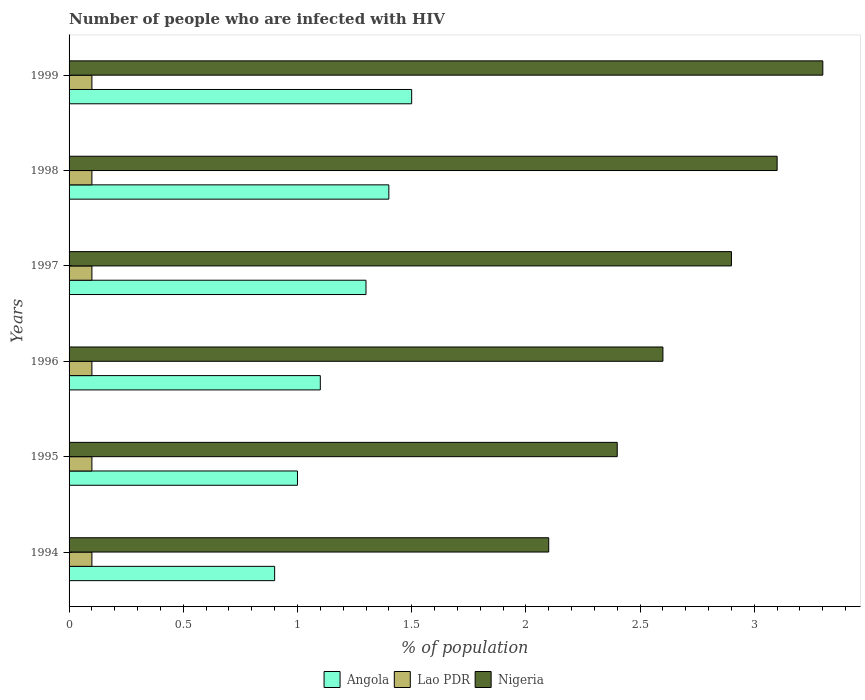How many different coloured bars are there?
Make the answer very short. 3. Are the number of bars per tick equal to the number of legend labels?
Keep it short and to the point. Yes. What is the label of the 4th group of bars from the top?
Your response must be concise. 1996. In how many cases, is the number of bars for a given year not equal to the number of legend labels?
Make the answer very short. 0. Across all years, what is the maximum percentage of HIV infected population in in Angola?
Your answer should be very brief. 1.5. Across all years, what is the minimum percentage of HIV infected population in in Nigeria?
Offer a very short reply. 2.1. In which year was the percentage of HIV infected population in in Angola minimum?
Ensure brevity in your answer.  1994. What is the total percentage of HIV infected population in in Nigeria in the graph?
Provide a short and direct response. 16.4. What is the difference between the percentage of HIV infected population in in Nigeria in 1997 and the percentage of HIV infected population in in Lao PDR in 1999?
Ensure brevity in your answer.  2.8. What is the average percentage of HIV infected population in in Angola per year?
Your answer should be very brief. 1.2. In the year 1995, what is the difference between the percentage of HIV infected population in in Nigeria and percentage of HIV infected population in in Angola?
Offer a very short reply. 1.4. In how many years, is the percentage of HIV infected population in in Lao PDR greater than 1.6 %?
Provide a succinct answer. 0. What is the ratio of the percentage of HIV infected population in in Lao PDR in 1995 to that in 1997?
Provide a succinct answer. 1. Is the percentage of HIV infected population in in Nigeria in 1994 less than that in 1995?
Keep it short and to the point. Yes. What is the difference between the highest and the second highest percentage of HIV infected population in in Angola?
Make the answer very short. 0.1. In how many years, is the percentage of HIV infected population in in Lao PDR greater than the average percentage of HIV infected population in in Lao PDR taken over all years?
Ensure brevity in your answer.  6. Is the sum of the percentage of HIV infected population in in Lao PDR in 1996 and 1997 greater than the maximum percentage of HIV infected population in in Nigeria across all years?
Provide a short and direct response. No. What does the 2nd bar from the top in 1995 represents?
Your response must be concise. Lao PDR. What does the 1st bar from the bottom in 1995 represents?
Give a very brief answer. Angola. Is it the case that in every year, the sum of the percentage of HIV infected population in in Angola and percentage of HIV infected population in in Lao PDR is greater than the percentage of HIV infected population in in Nigeria?
Provide a succinct answer. No. Are the values on the major ticks of X-axis written in scientific E-notation?
Keep it short and to the point. No. Does the graph contain any zero values?
Your answer should be very brief. No. Does the graph contain grids?
Give a very brief answer. No. How many legend labels are there?
Provide a succinct answer. 3. How are the legend labels stacked?
Your response must be concise. Horizontal. What is the title of the graph?
Keep it short and to the point. Number of people who are infected with HIV. Does "Italy" appear as one of the legend labels in the graph?
Provide a succinct answer. No. What is the label or title of the X-axis?
Give a very brief answer. % of population. What is the label or title of the Y-axis?
Your response must be concise. Years. What is the % of population in Angola in 1994?
Make the answer very short. 0.9. What is the % of population of Lao PDR in 1994?
Keep it short and to the point. 0.1. What is the % of population in Nigeria in 1994?
Your response must be concise. 2.1. What is the % of population in Angola in 1995?
Your response must be concise. 1. What is the % of population of Nigeria in 1995?
Your answer should be compact. 2.4. What is the % of population in Angola in 1996?
Make the answer very short. 1.1. What is the % of population of Lao PDR in 1996?
Give a very brief answer. 0.1. What is the % of population in Angola in 1998?
Keep it short and to the point. 1.4. What is the % of population of Nigeria in 1998?
Provide a short and direct response. 3.1. What is the % of population in Lao PDR in 1999?
Your answer should be very brief. 0.1. Across all years, what is the maximum % of population in Lao PDR?
Give a very brief answer. 0.1. Across all years, what is the minimum % of population of Angola?
Make the answer very short. 0.9. What is the total % of population of Angola in the graph?
Provide a short and direct response. 7.2. What is the difference between the % of population in Lao PDR in 1994 and that in 1995?
Your answer should be compact. 0. What is the difference between the % of population of Nigeria in 1994 and that in 1995?
Keep it short and to the point. -0.3. What is the difference between the % of population in Lao PDR in 1994 and that in 1996?
Your response must be concise. 0. What is the difference between the % of population of Nigeria in 1994 and that in 1996?
Provide a succinct answer. -0.5. What is the difference between the % of population of Lao PDR in 1994 and that in 1997?
Ensure brevity in your answer.  0. What is the difference between the % of population of Angola in 1994 and that in 1998?
Offer a terse response. -0.5. What is the difference between the % of population in Nigeria in 1994 and that in 1998?
Give a very brief answer. -1. What is the difference between the % of population in Nigeria in 1994 and that in 1999?
Your response must be concise. -1.2. What is the difference between the % of population of Angola in 1995 and that in 1998?
Keep it short and to the point. -0.4. What is the difference between the % of population of Nigeria in 1995 and that in 1998?
Give a very brief answer. -0.7. What is the difference between the % of population of Angola in 1995 and that in 1999?
Your response must be concise. -0.5. What is the difference between the % of population in Angola in 1996 and that in 1997?
Provide a short and direct response. -0.2. What is the difference between the % of population of Nigeria in 1996 and that in 1997?
Offer a terse response. -0.3. What is the difference between the % of population in Lao PDR in 1996 and that in 1999?
Offer a very short reply. 0. What is the difference between the % of population of Nigeria in 1996 and that in 1999?
Your response must be concise. -0.7. What is the difference between the % of population of Lao PDR in 1997 and that in 1998?
Make the answer very short. 0. What is the difference between the % of population of Angola in 1997 and that in 1999?
Give a very brief answer. -0.2. What is the difference between the % of population of Lao PDR in 1997 and that in 1999?
Offer a terse response. 0. What is the difference between the % of population in Nigeria in 1998 and that in 1999?
Make the answer very short. -0.2. What is the difference between the % of population of Angola in 1994 and the % of population of Lao PDR in 1995?
Make the answer very short. 0.8. What is the difference between the % of population of Lao PDR in 1994 and the % of population of Nigeria in 1995?
Your answer should be compact. -2.3. What is the difference between the % of population of Angola in 1994 and the % of population of Nigeria in 1996?
Offer a terse response. -1.7. What is the difference between the % of population in Angola in 1994 and the % of population in Lao PDR in 1997?
Make the answer very short. 0.8. What is the difference between the % of population in Lao PDR in 1994 and the % of population in Nigeria in 1997?
Ensure brevity in your answer.  -2.8. What is the difference between the % of population of Angola in 1994 and the % of population of Nigeria in 1998?
Your answer should be compact. -2.2. What is the difference between the % of population in Angola in 1994 and the % of population in Nigeria in 1999?
Make the answer very short. -2.4. What is the difference between the % of population of Angola in 1995 and the % of population of Lao PDR in 1996?
Your answer should be very brief. 0.9. What is the difference between the % of population in Angola in 1995 and the % of population in Nigeria in 1997?
Give a very brief answer. -1.9. What is the difference between the % of population of Lao PDR in 1995 and the % of population of Nigeria in 1999?
Keep it short and to the point. -3.2. What is the difference between the % of population in Angola in 1996 and the % of population in Lao PDR in 1997?
Keep it short and to the point. 1. What is the difference between the % of population in Angola in 1996 and the % of population in Lao PDR in 1998?
Your answer should be very brief. 1. What is the difference between the % of population in Angola in 1996 and the % of population in Nigeria in 1998?
Offer a terse response. -2. What is the difference between the % of population of Angola in 1996 and the % of population of Lao PDR in 1999?
Give a very brief answer. 1. What is the difference between the % of population in Lao PDR in 1996 and the % of population in Nigeria in 1999?
Keep it short and to the point. -3.2. What is the difference between the % of population of Angola in 1997 and the % of population of Nigeria in 1998?
Offer a terse response. -1.8. What is the difference between the % of population in Lao PDR in 1997 and the % of population in Nigeria in 1998?
Make the answer very short. -3. What is the difference between the % of population of Angola in 1997 and the % of population of Nigeria in 1999?
Offer a very short reply. -2. What is the difference between the % of population of Angola in 1998 and the % of population of Lao PDR in 1999?
Provide a succinct answer. 1.3. What is the difference between the % of population of Angola in 1998 and the % of population of Nigeria in 1999?
Your answer should be very brief. -1.9. What is the difference between the % of population of Lao PDR in 1998 and the % of population of Nigeria in 1999?
Offer a terse response. -3.2. What is the average % of population in Angola per year?
Your response must be concise. 1.2. What is the average % of population in Lao PDR per year?
Offer a terse response. 0.1. What is the average % of population in Nigeria per year?
Provide a succinct answer. 2.73. In the year 1994, what is the difference between the % of population of Angola and % of population of Lao PDR?
Provide a short and direct response. 0.8. In the year 1994, what is the difference between the % of population in Angola and % of population in Nigeria?
Offer a very short reply. -1.2. In the year 1995, what is the difference between the % of population of Lao PDR and % of population of Nigeria?
Keep it short and to the point. -2.3. In the year 1996, what is the difference between the % of population of Angola and % of population of Lao PDR?
Offer a very short reply. 1. In the year 1998, what is the difference between the % of population of Lao PDR and % of population of Nigeria?
Your answer should be compact. -3. In the year 1999, what is the difference between the % of population of Angola and % of population of Lao PDR?
Keep it short and to the point. 1.4. In the year 1999, what is the difference between the % of population of Angola and % of population of Nigeria?
Give a very brief answer. -1.8. In the year 1999, what is the difference between the % of population in Lao PDR and % of population in Nigeria?
Your answer should be very brief. -3.2. What is the ratio of the % of population of Angola in 1994 to that in 1995?
Your response must be concise. 0.9. What is the ratio of the % of population of Lao PDR in 1994 to that in 1995?
Your answer should be very brief. 1. What is the ratio of the % of population in Angola in 1994 to that in 1996?
Make the answer very short. 0.82. What is the ratio of the % of population in Lao PDR in 1994 to that in 1996?
Provide a succinct answer. 1. What is the ratio of the % of population in Nigeria in 1994 to that in 1996?
Provide a succinct answer. 0.81. What is the ratio of the % of population of Angola in 1994 to that in 1997?
Your response must be concise. 0.69. What is the ratio of the % of population in Lao PDR in 1994 to that in 1997?
Your answer should be very brief. 1. What is the ratio of the % of population of Nigeria in 1994 to that in 1997?
Make the answer very short. 0.72. What is the ratio of the % of population in Angola in 1994 to that in 1998?
Make the answer very short. 0.64. What is the ratio of the % of population in Lao PDR in 1994 to that in 1998?
Ensure brevity in your answer.  1. What is the ratio of the % of population in Nigeria in 1994 to that in 1998?
Keep it short and to the point. 0.68. What is the ratio of the % of population in Nigeria in 1994 to that in 1999?
Offer a very short reply. 0.64. What is the ratio of the % of population of Angola in 1995 to that in 1996?
Make the answer very short. 0.91. What is the ratio of the % of population in Lao PDR in 1995 to that in 1996?
Keep it short and to the point. 1. What is the ratio of the % of population in Nigeria in 1995 to that in 1996?
Keep it short and to the point. 0.92. What is the ratio of the % of population of Angola in 1995 to that in 1997?
Ensure brevity in your answer.  0.77. What is the ratio of the % of population of Lao PDR in 1995 to that in 1997?
Your answer should be very brief. 1. What is the ratio of the % of population in Nigeria in 1995 to that in 1997?
Give a very brief answer. 0.83. What is the ratio of the % of population in Angola in 1995 to that in 1998?
Offer a terse response. 0.71. What is the ratio of the % of population of Nigeria in 1995 to that in 1998?
Offer a very short reply. 0.77. What is the ratio of the % of population in Angola in 1995 to that in 1999?
Make the answer very short. 0.67. What is the ratio of the % of population in Nigeria in 1995 to that in 1999?
Your response must be concise. 0.73. What is the ratio of the % of population of Angola in 1996 to that in 1997?
Offer a very short reply. 0.85. What is the ratio of the % of population of Nigeria in 1996 to that in 1997?
Your answer should be very brief. 0.9. What is the ratio of the % of population of Angola in 1996 to that in 1998?
Give a very brief answer. 0.79. What is the ratio of the % of population in Lao PDR in 1996 to that in 1998?
Your answer should be very brief. 1. What is the ratio of the % of population in Nigeria in 1996 to that in 1998?
Your answer should be very brief. 0.84. What is the ratio of the % of population in Angola in 1996 to that in 1999?
Your response must be concise. 0.73. What is the ratio of the % of population of Nigeria in 1996 to that in 1999?
Your answer should be compact. 0.79. What is the ratio of the % of population of Angola in 1997 to that in 1998?
Your response must be concise. 0.93. What is the ratio of the % of population in Lao PDR in 1997 to that in 1998?
Your answer should be compact. 1. What is the ratio of the % of population in Nigeria in 1997 to that in 1998?
Offer a very short reply. 0.94. What is the ratio of the % of population in Angola in 1997 to that in 1999?
Your answer should be compact. 0.87. What is the ratio of the % of population of Nigeria in 1997 to that in 1999?
Offer a terse response. 0.88. What is the ratio of the % of population of Nigeria in 1998 to that in 1999?
Make the answer very short. 0.94. What is the difference between the highest and the second highest % of population in Nigeria?
Your response must be concise. 0.2. What is the difference between the highest and the lowest % of population in Nigeria?
Your answer should be compact. 1.2. 